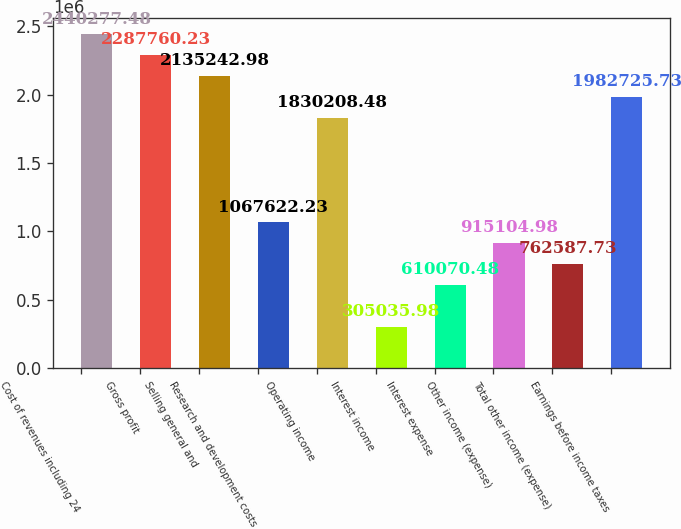<chart> <loc_0><loc_0><loc_500><loc_500><bar_chart><fcel>Cost of revenues including 24<fcel>Gross profit<fcel>Selling general and<fcel>Research and development costs<fcel>Operating income<fcel>Interest income<fcel>Interest expense<fcel>Other income (expense)<fcel>Total other income (expense)<fcel>Earnings before income taxes<nl><fcel>2.44028e+06<fcel>2.28776e+06<fcel>2.13524e+06<fcel>1.06762e+06<fcel>1.83021e+06<fcel>305036<fcel>610070<fcel>915105<fcel>762588<fcel>1.98273e+06<nl></chart> 